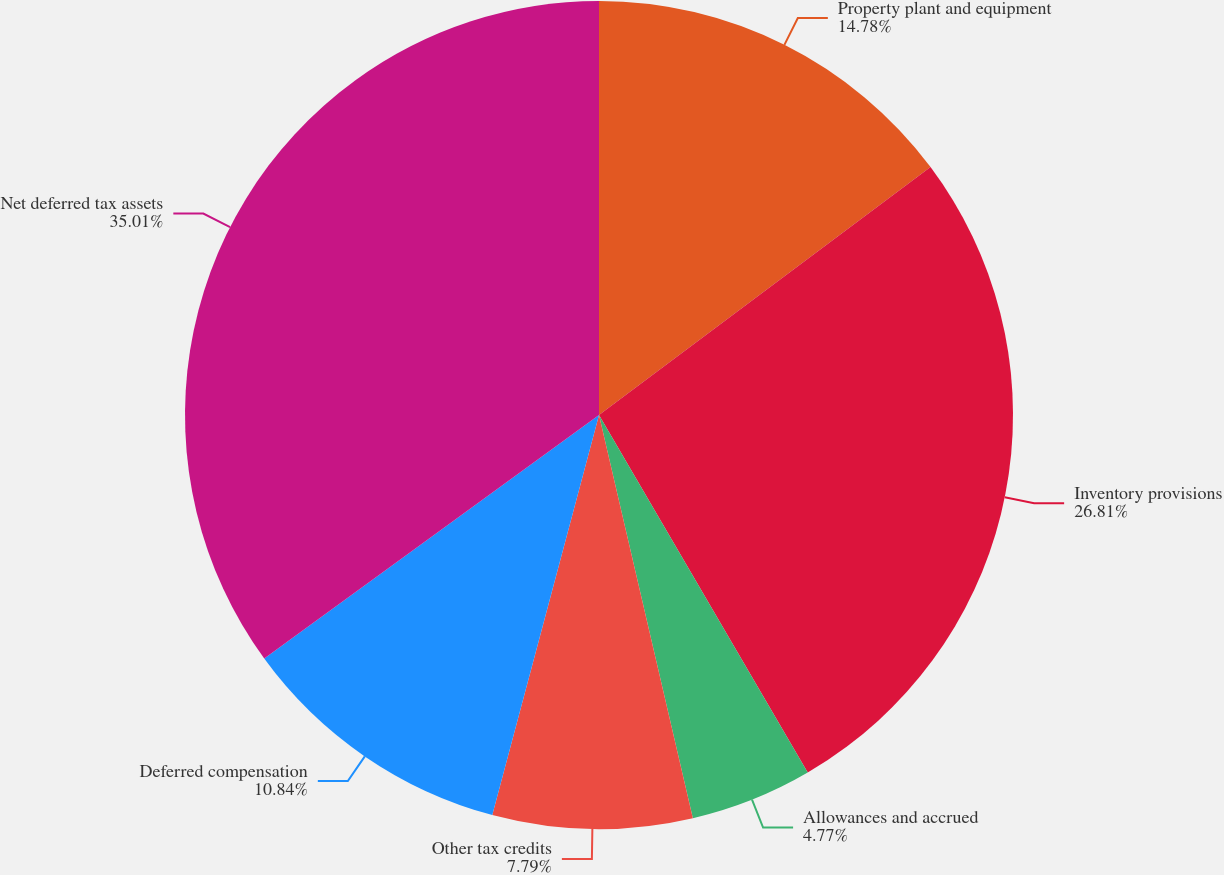<chart> <loc_0><loc_0><loc_500><loc_500><pie_chart><fcel>Property plant and equipment<fcel>Inventory provisions<fcel>Allowances and accrued<fcel>Other tax credits<fcel>Deferred compensation<fcel>Net deferred tax assets<nl><fcel>14.78%<fcel>26.81%<fcel>4.77%<fcel>7.79%<fcel>10.84%<fcel>35.01%<nl></chart> 